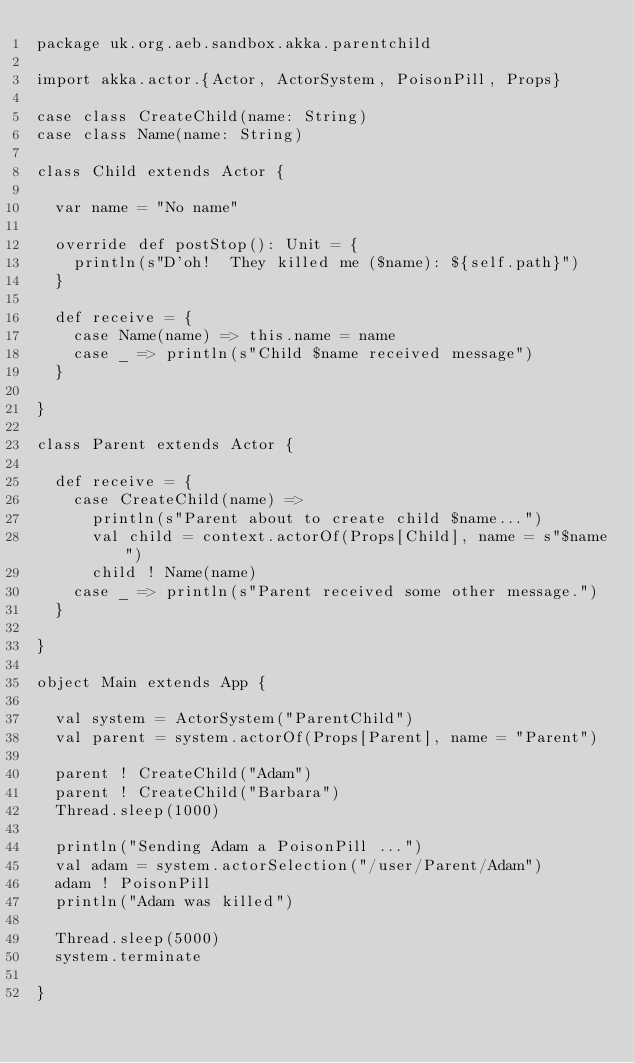Convert code to text. <code><loc_0><loc_0><loc_500><loc_500><_Scala_>package uk.org.aeb.sandbox.akka.parentchild

import akka.actor.{Actor, ActorSystem, PoisonPill, Props}

case class CreateChild(name: String)
case class Name(name: String)

class Child extends Actor {

  var name = "No name"

  override def postStop(): Unit = {
    println(s"D'oh!  They killed me ($name): ${self.path}")
  }

  def receive = {
    case Name(name) => this.name = name
    case _ => println(s"Child $name received message")
  }

}

class Parent extends Actor {

  def receive = {
    case CreateChild(name) =>
      println(s"Parent about to create child $name...")
      val child = context.actorOf(Props[Child], name = s"$name")
      child ! Name(name)
    case _ => println(s"Parent received some other message.")
  }

}

object Main extends App {

  val system = ActorSystem("ParentChild")
  val parent = system.actorOf(Props[Parent], name = "Parent")

  parent ! CreateChild("Adam")
  parent ! CreateChild("Barbara")
  Thread.sleep(1000)

  println("Sending Adam a PoisonPill ...")
  val adam = system.actorSelection("/user/Parent/Adam")
  adam ! PoisonPill
  println("Adam was killed")

  Thread.sleep(5000)
  system.terminate

}
</code> 